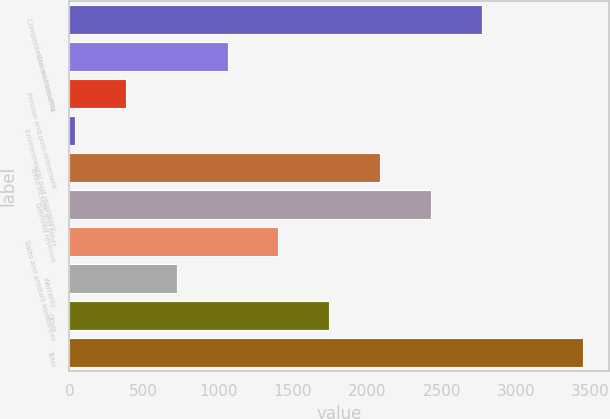Convert chart to OTSL. <chart><loc_0><loc_0><loc_500><loc_500><bar_chart><fcel>Compensation and benefits<fcel>Claims including<fcel>Pension and post-retirement<fcel>Environmental and regulatory<fcel>Taxes income and other<fcel>Deferred revenue<fcel>Sales and product allowances<fcel>Warranty<fcel>Other<fcel>Total<nl><fcel>2767.74<fcel>1063.34<fcel>381.58<fcel>40.7<fcel>2085.98<fcel>2426.86<fcel>1404.22<fcel>722.46<fcel>1745.1<fcel>3449.5<nl></chart> 